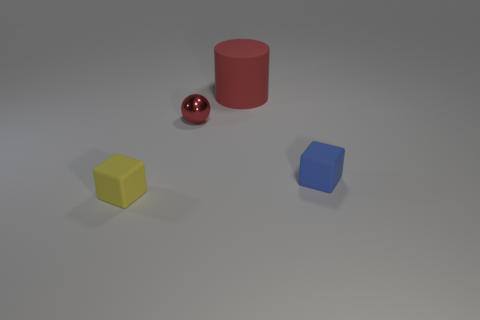How would you describe the composition of this image? The composition of this image is fairly minimalistic, with ample negative space that draws attention to the objects placed asymmetrically within the frame. The red metallic ball, being the most vibrant and reflective object, naturally becomes the focal point. 